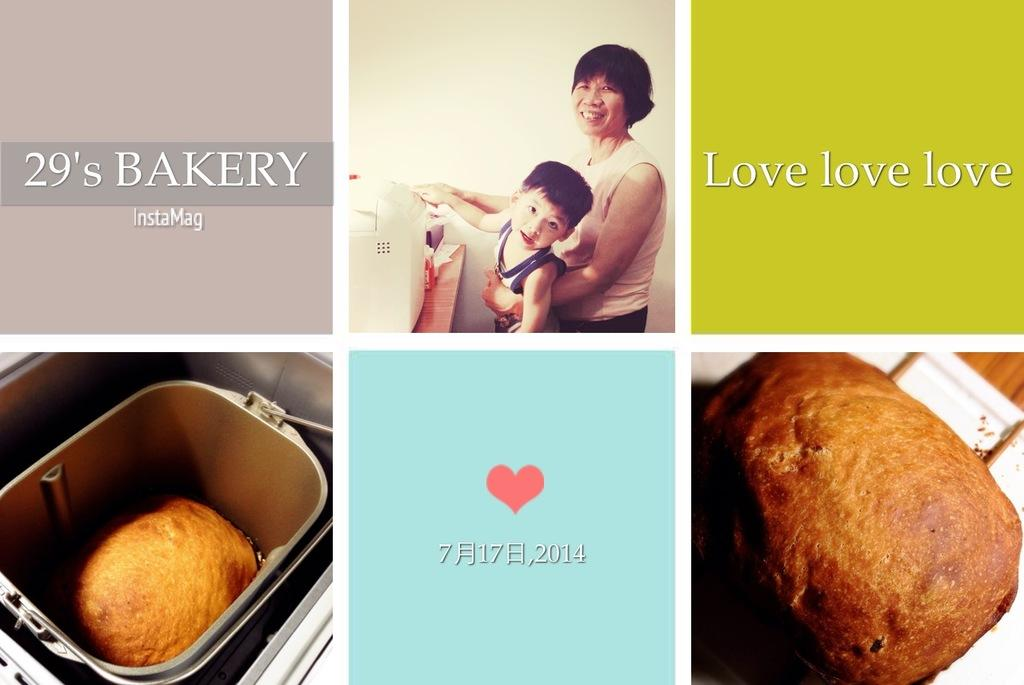<image>
Offer a succinct explanation of the picture presented. A mother carrying her child appears to the right of text that reads 29's bakery. 